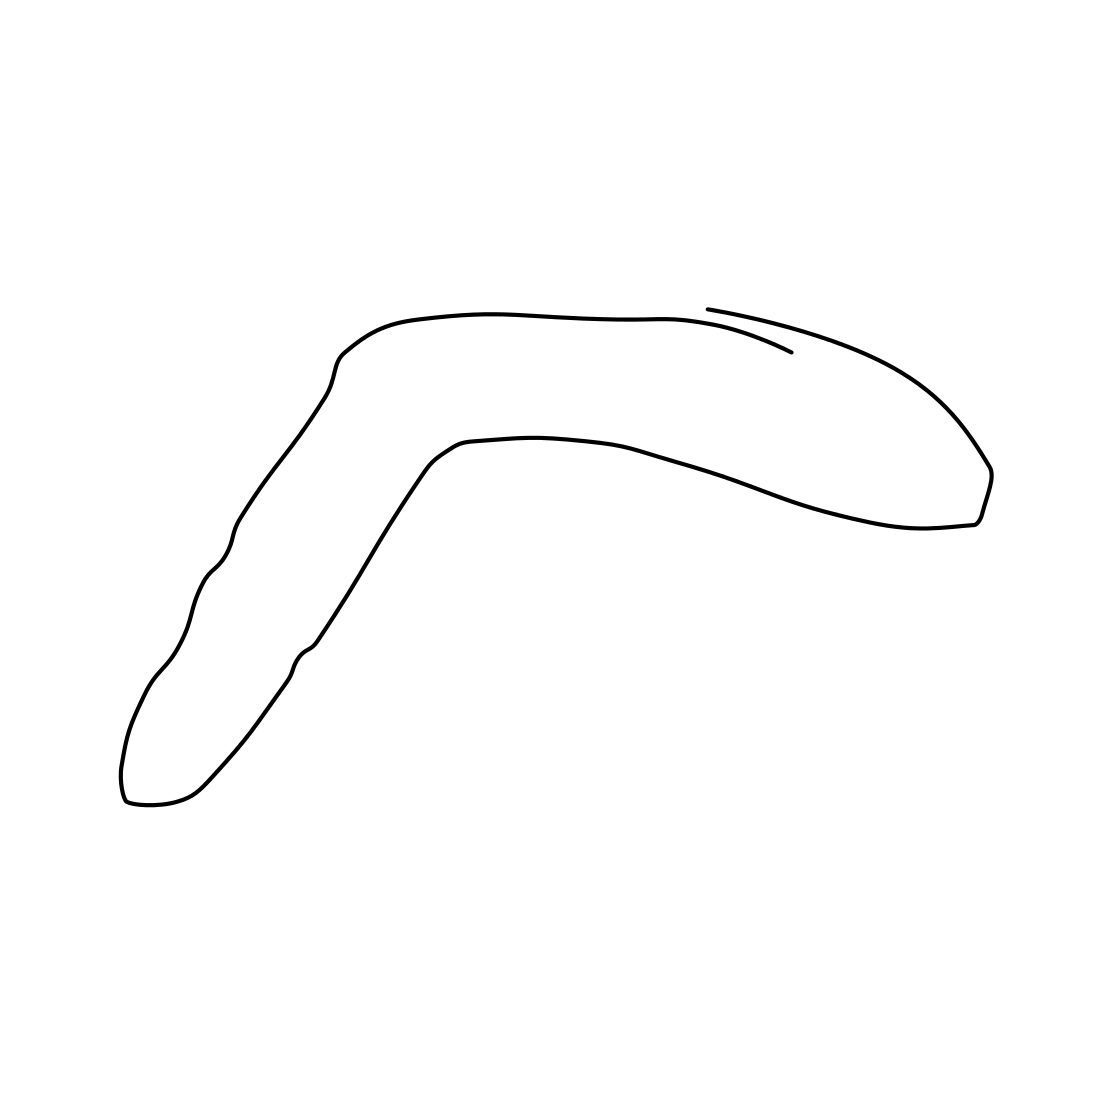Is there a sketchy mermaid in the picture? No, there isn't a sketchy mermaid in the image. The drawing instead represents a simple boomerang-like shape, characterized by its curved line and narrow silhouette. There are no details that suggest it is a mermaid, as it lacks distinct features like a human figure or aquatic elements typically associated with mermaids. 